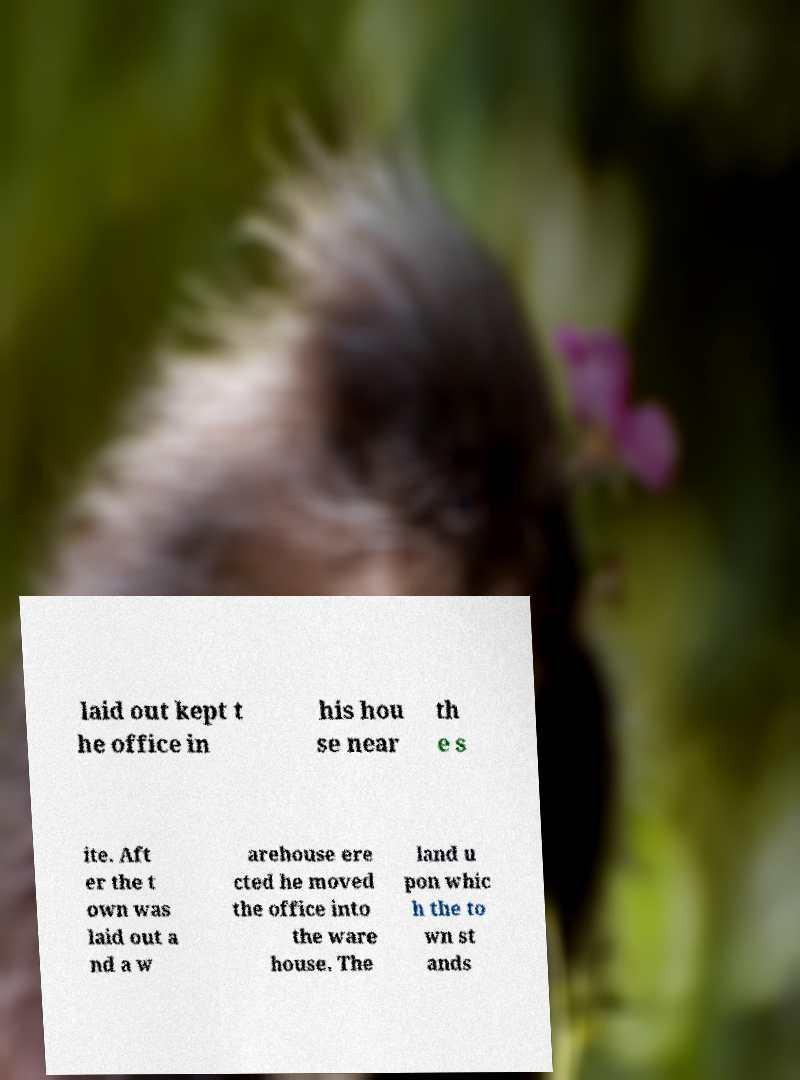For documentation purposes, I need the text within this image transcribed. Could you provide that? laid out kept t he office in his hou se near th e s ite. Aft er the t own was laid out a nd a w arehouse ere cted he moved the office into the ware house. The land u pon whic h the to wn st ands 